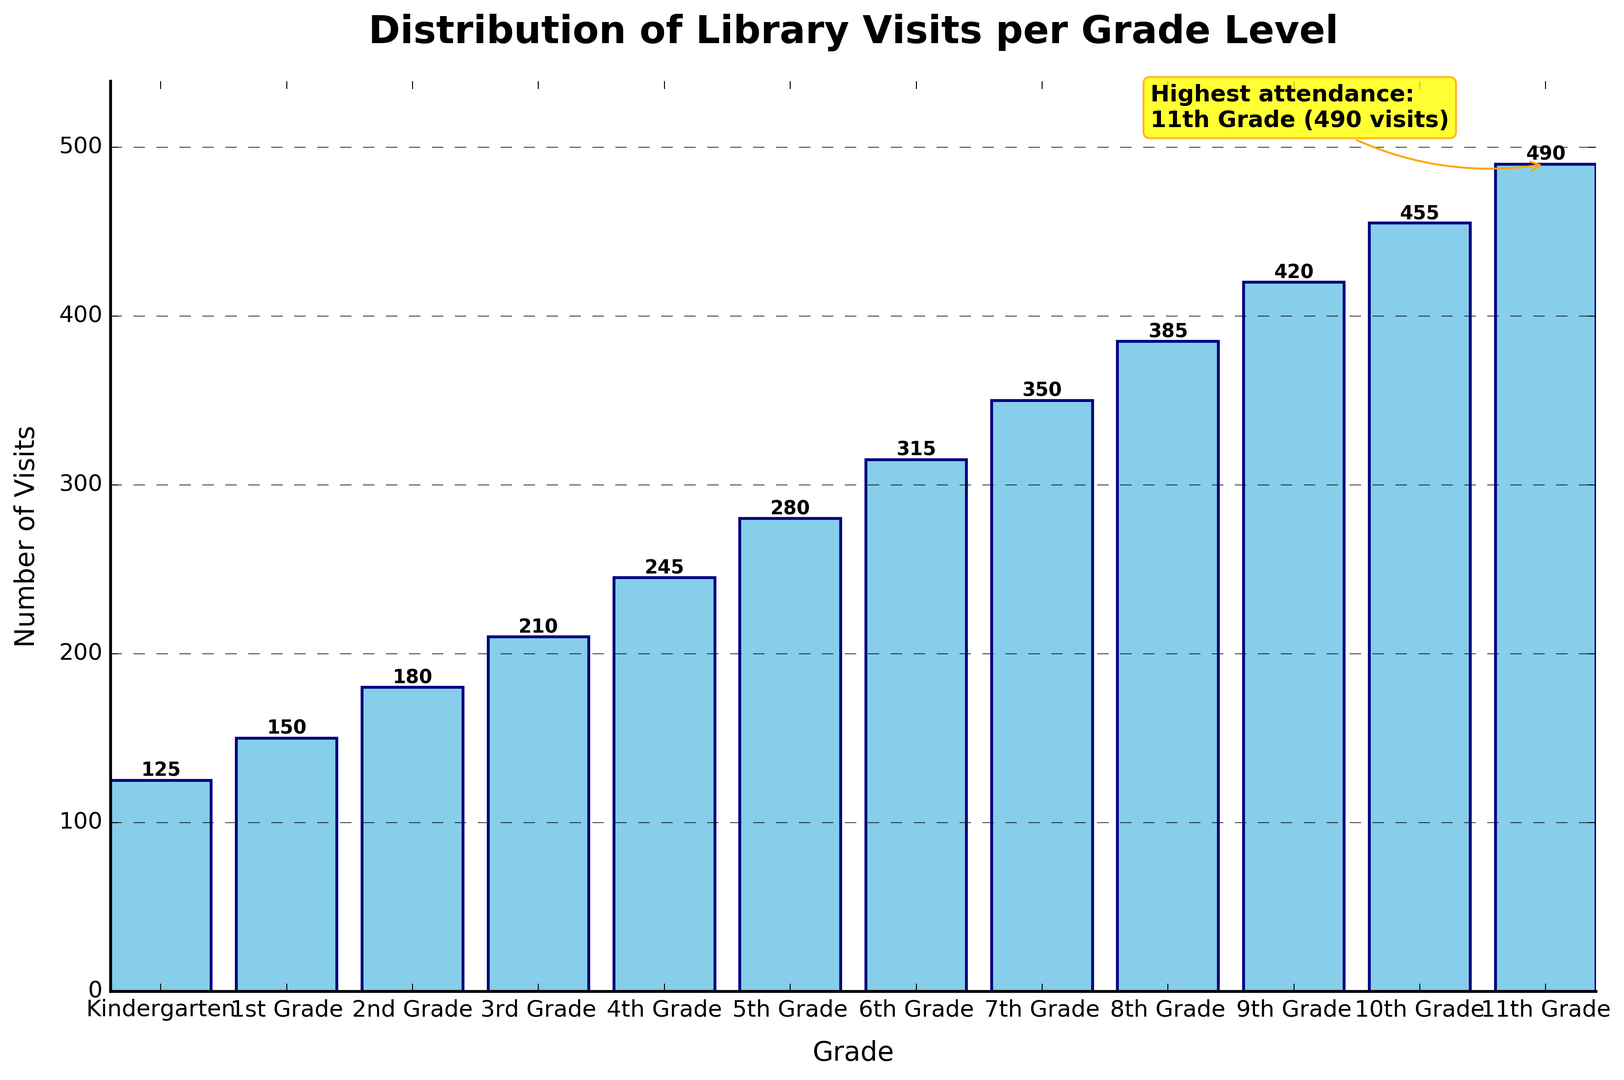Which grade level has the highest number of library visits? The chart shows the number of library visits per grade level with an annotation marking the highest attendance. The annotation indicates "11th Grade (490 visits)" as the highest.
Answer: 11th Grade What is the difference in library visits between 5th Grade and 11th Grade? The chart lists the visits for each grade: 5th Grade has 280 visits, and 11th Grade has 490 visits. Subtracting the smaller number from the larger number gives 490 - 280.
Answer: 210 Identify the grade levels with fewer than 200 library visits. By looking at the heights of the bars and the numerical labels, grades with fewer than 200 visits are Kindergarten (125), 1st Grade (150), and 2nd Grade (180).
Answer: Kindergarten, 1st Grade, 2nd Grade How many more visits does 10th Grade have compared to 7th Grade? The chart shows that 10th Grade has 455 visits and 7th Grade has 350 visits. Subtract 350 from 455 to get the difference.
Answer: 105 What is the average number of library visits for the grades from Kindergarten to 4th Grade? Add the visits for Kindergarten (125), 1st Grade (150), 2nd Grade (180), 3rd Grade (210), and 4th Grade (245) to get a total, then divide by the number of grades (5). (125 + 150 + 180 + 210 + 245) / 5 = 182
Answer: 182 Which grade level has library visits closest to 400? By examining the height of the bars and their labels, 9th Grade with 420 visits is the closest to 400.
Answer: 9th Grade Do the number of visits generally increase or decrease as grade levels progress from Kindergarten to 11th Grade? Observing the trend in the chart, the number of visits increases consistently for each successive grade level.
Answer: Increase 